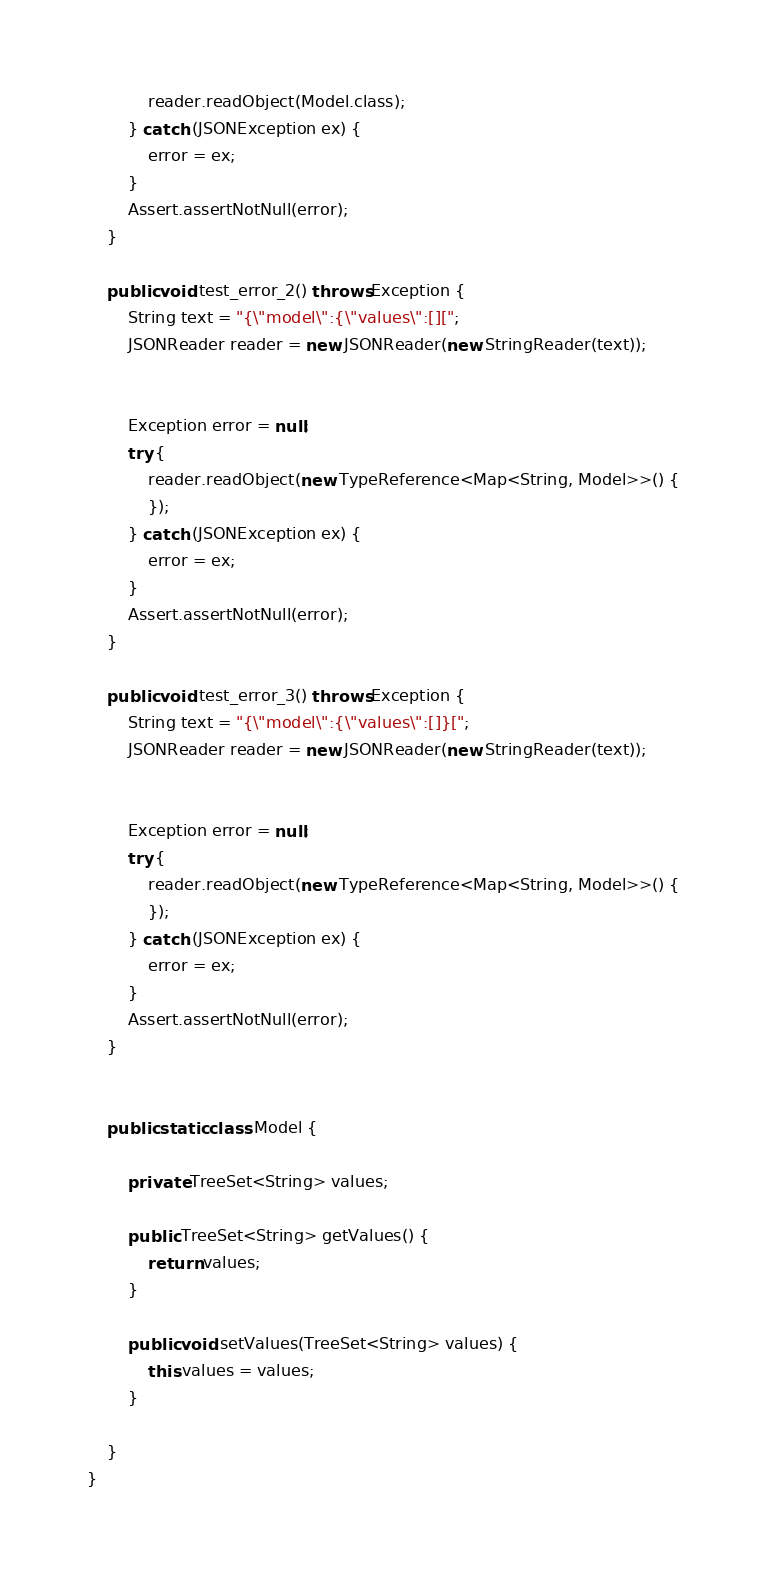Convert code to text. <code><loc_0><loc_0><loc_500><loc_500><_Java_>            reader.readObject(Model.class);
        } catch (JSONException ex) {
            error = ex;
        }
        Assert.assertNotNull(error);
    }
    
    public void test_error_2() throws Exception {
        String text = "{\"model\":{\"values\":[][";
        JSONReader reader = new JSONReader(new StringReader(text));
        

        Exception error = null;
        try {
            reader.readObject(new TypeReference<Map<String, Model>>() {
            });
        } catch (JSONException ex) {
            error = ex;
        }
        Assert.assertNotNull(error);
    }
    
    public void test_error_3() throws Exception {
        String text = "{\"model\":{\"values\":[]}[";
        JSONReader reader = new JSONReader(new StringReader(text));
        

        Exception error = null;
        try {
            reader.readObject(new TypeReference<Map<String, Model>>() {
            });
        } catch (JSONException ex) {
            error = ex;
        }
        Assert.assertNotNull(error);
    }
    

    public static class Model {

        private TreeSet<String> values;

        public TreeSet<String> getValues() {
            return values;
        }

        public void setValues(TreeSet<String> values) {
            this.values = values;
        }

    }
}
</code> 